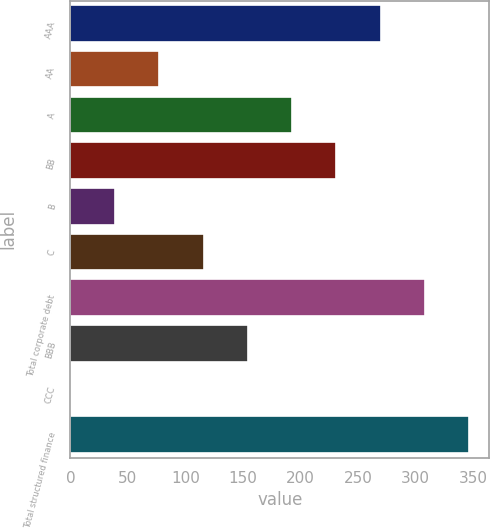Convert chart to OTSL. <chart><loc_0><loc_0><loc_500><loc_500><bar_chart><fcel>AAA<fcel>AA<fcel>A<fcel>BB<fcel>B<fcel>C<fcel>Total corporate debt<fcel>BBB<fcel>CCC<fcel>Total structured finance<nl><fcel>269.69<fcel>77.34<fcel>192.75<fcel>231.22<fcel>38.87<fcel>115.81<fcel>308.16<fcel>154.28<fcel>0.4<fcel>346.63<nl></chart> 